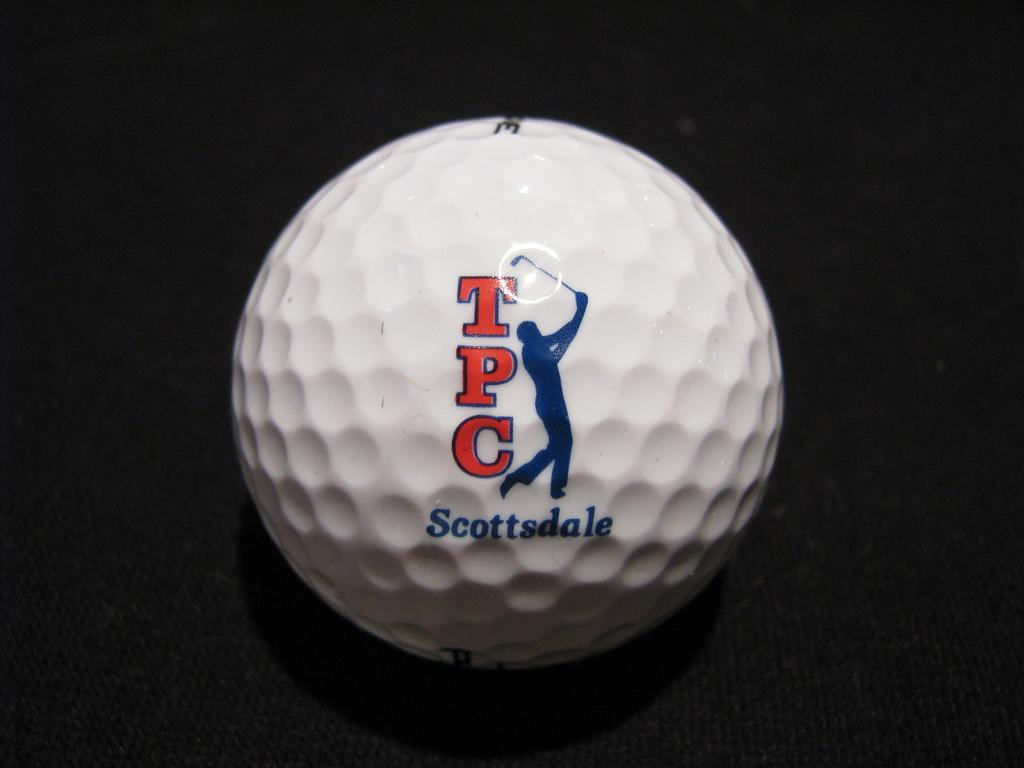Provide a one-sentence caption for the provided image. A white golf ball that says TPC Scottsdale. 